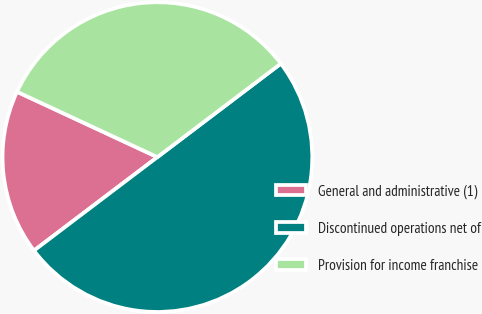Convert chart to OTSL. <chart><loc_0><loc_0><loc_500><loc_500><pie_chart><fcel>General and administrative (1)<fcel>Discontinued operations net of<fcel>Provision for income franchise<nl><fcel>17.25%<fcel>50.0%<fcel>32.75%<nl></chart> 